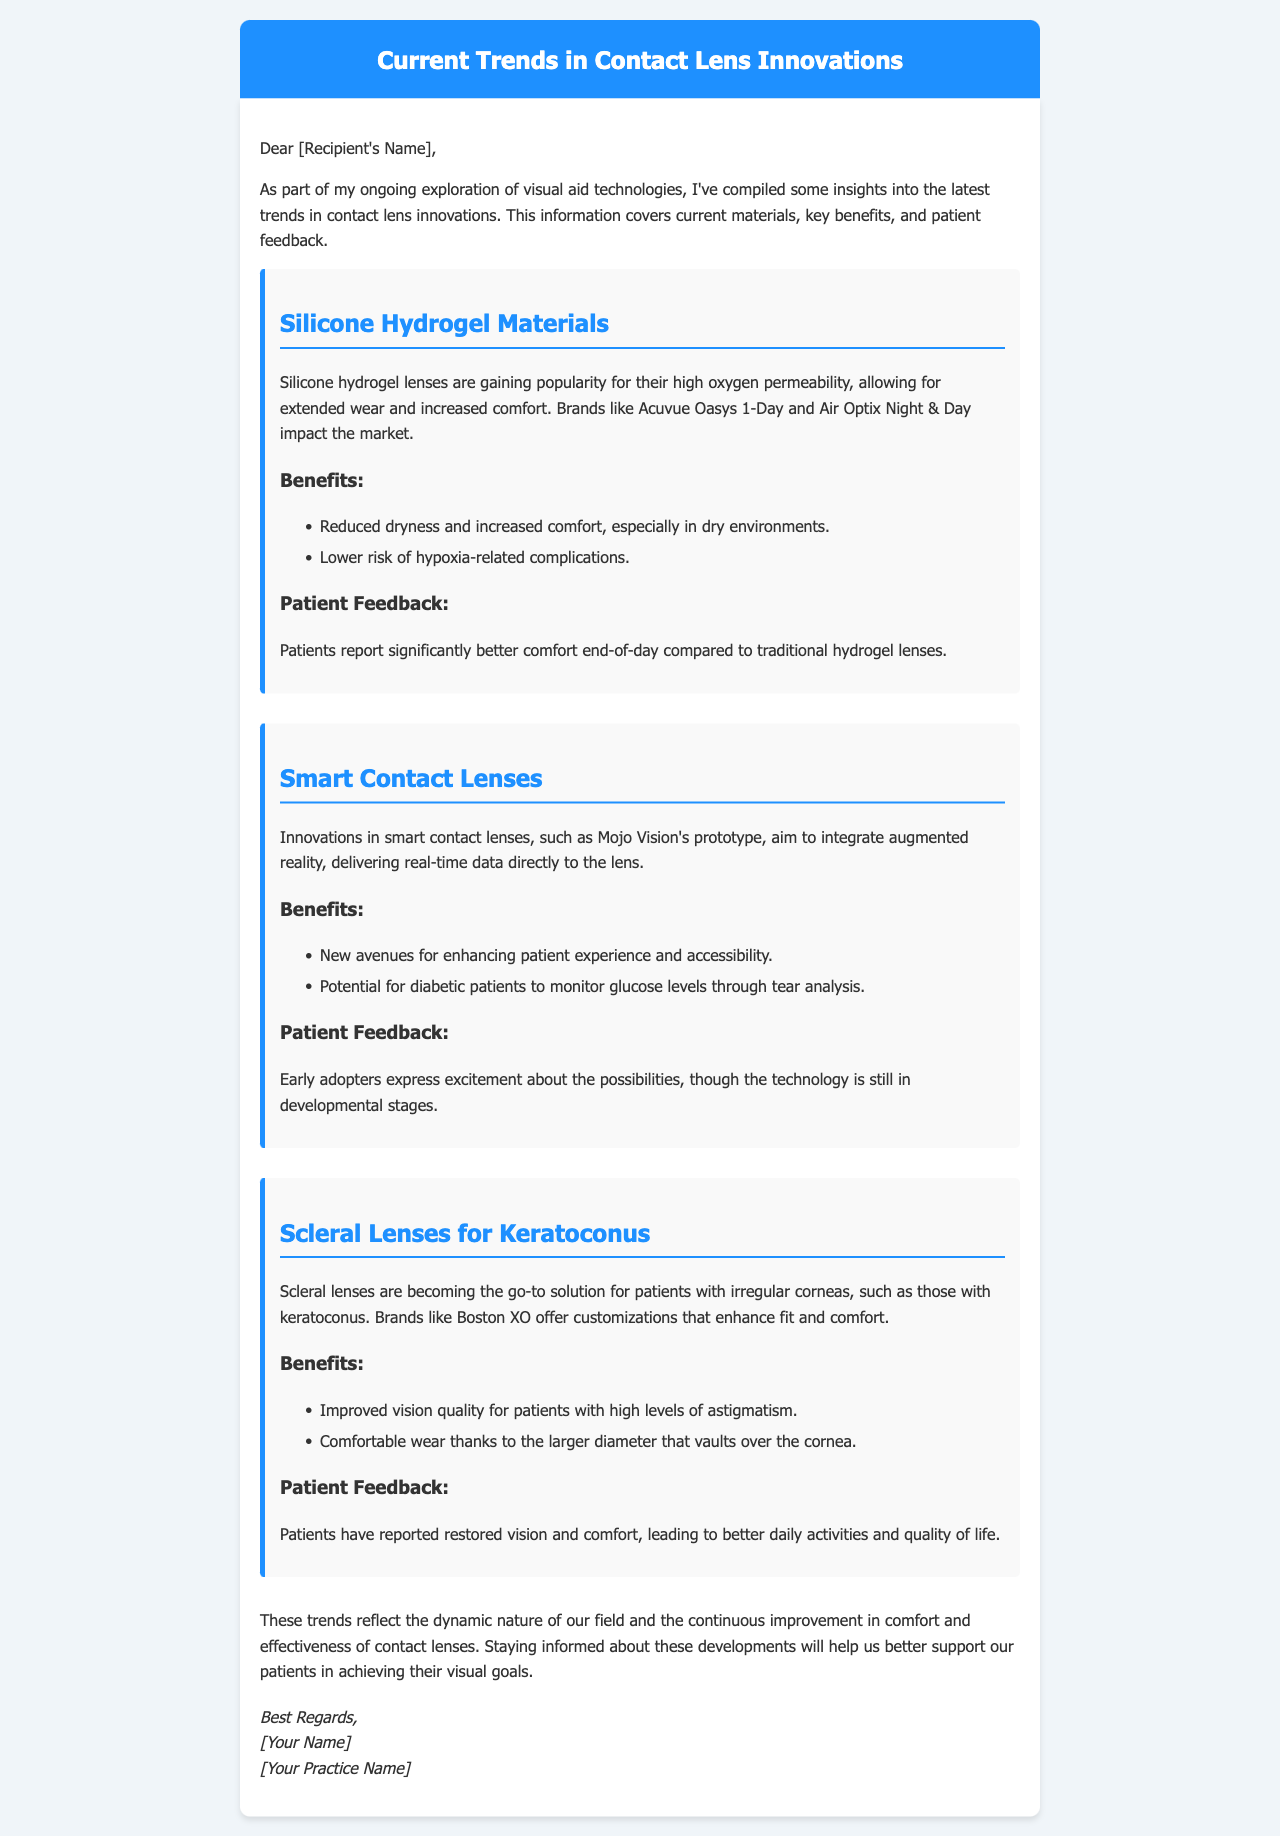what is the title of the document? The title is located at the top of the email, summarizing the content about contact lens innovations.
Answer: Current Trends in Contact Lens Innovations what type of lenses are highlighted for their high oxygen permeability? This information is about a specific type of contact lens noted for its popularity and comfort features.
Answer: Silicone Hydrogel Materials what is one major benefit of silicone hydrogel lenses? This is a specific benefit listed within the content related to silicone hydrogel lenses.
Answer: Reduced dryness and increased comfort which brand is mentioned as offering scleral lenses? The brand is listed in the context of providing solutions for patients with specific eye conditions.
Answer: Boston XO what patient feedback is associated with smart contact lenses? This feedback indicates users' sentiment and reactions to a newer technology mentioned.
Answer: Early adopters express excitement about the possibilities how do scleral lenses help patients with keratoconus? This requires reasoning about the specific functionality of scleral lenses as described in the email.
Answer: Improved vision quality which lens type is designed for diabetic patients monitoring glucose levels? This question pertains to a specific innovation in the contact lens market mentioned in the report.
Answer: Smart Contact Lenses what is the primary purpose of the document? This question focuses on the overall aim of the email as stated in the introduction.
Answer: To provide insights into current trends in contact lens innovations 